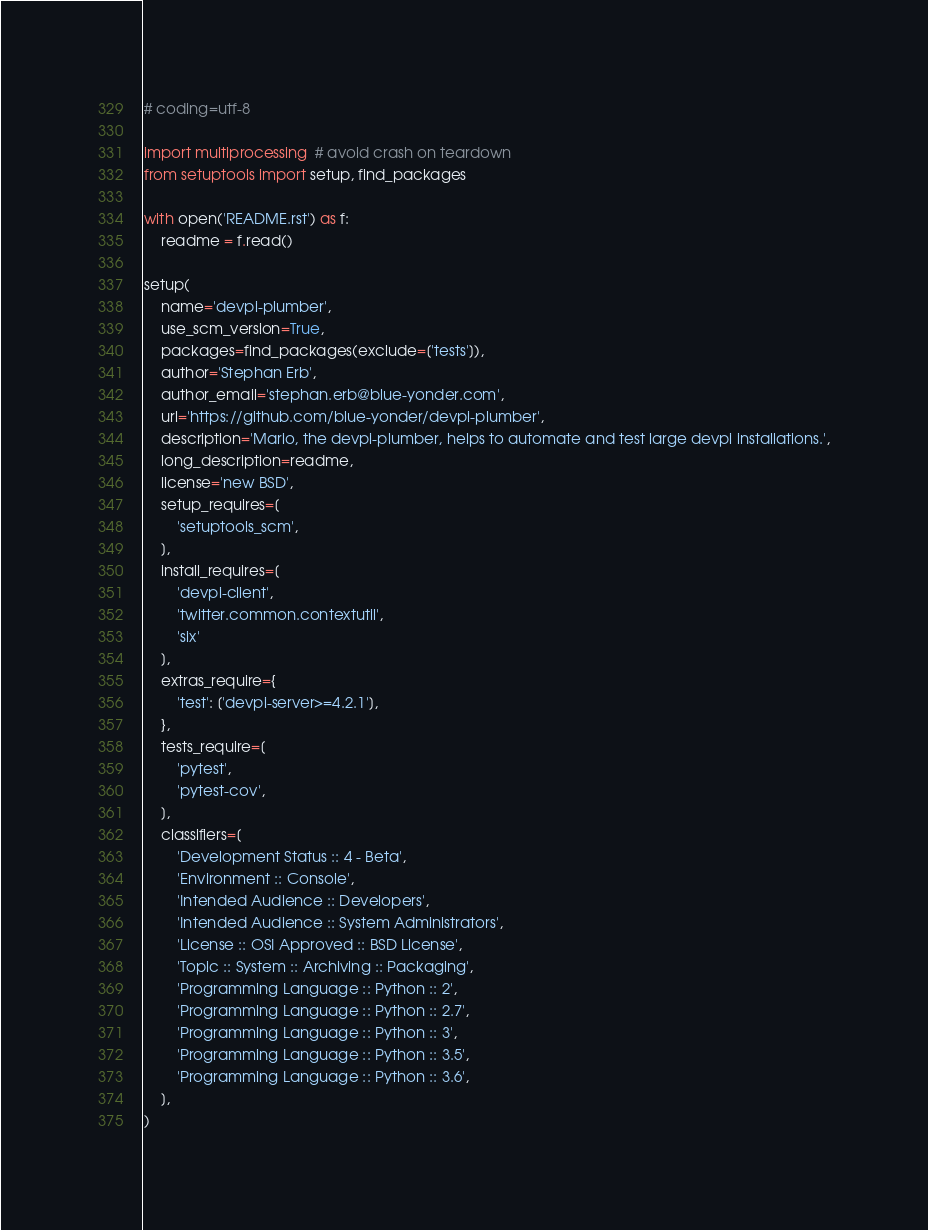Convert code to text. <code><loc_0><loc_0><loc_500><loc_500><_Python_># coding=utf-8

import multiprocessing  # avoid crash on teardown
from setuptools import setup, find_packages

with open('README.rst') as f:
    readme = f.read()

setup(
    name='devpi-plumber',
    use_scm_version=True,
    packages=find_packages(exclude=['tests']),
    author='Stephan Erb',
    author_email='stephan.erb@blue-yonder.com',
    url='https://github.com/blue-yonder/devpi-plumber',
    description='Mario, the devpi-plumber, helps to automate and test large devpi installations.',
    long_description=readme,
    license='new BSD',
    setup_requires=[
        'setuptools_scm',
    ],
    install_requires=[
        'devpi-client',
        'twitter.common.contextutil',
        'six'
    ],
    extras_require={
        'test': ['devpi-server>=4.2.1'],
    },
    tests_require=[
        'pytest',
        'pytest-cov',
    ],
    classifiers=[
        'Development Status :: 4 - Beta',
        'Environment :: Console',
        'Intended Audience :: Developers',
        'Intended Audience :: System Administrators',
        'License :: OSI Approved :: BSD License',
        'Topic :: System :: Archiving :: Packaging',
        'Programming Language :: Python :: 2',
        'Programming Language :: Python :: 2.7',
        'Programming Language :: Python :: 3',
        'Programming Language :: Python :: 3.5',
        'Programming Language :: Python :: 3.6',
    ],
)
</code> 